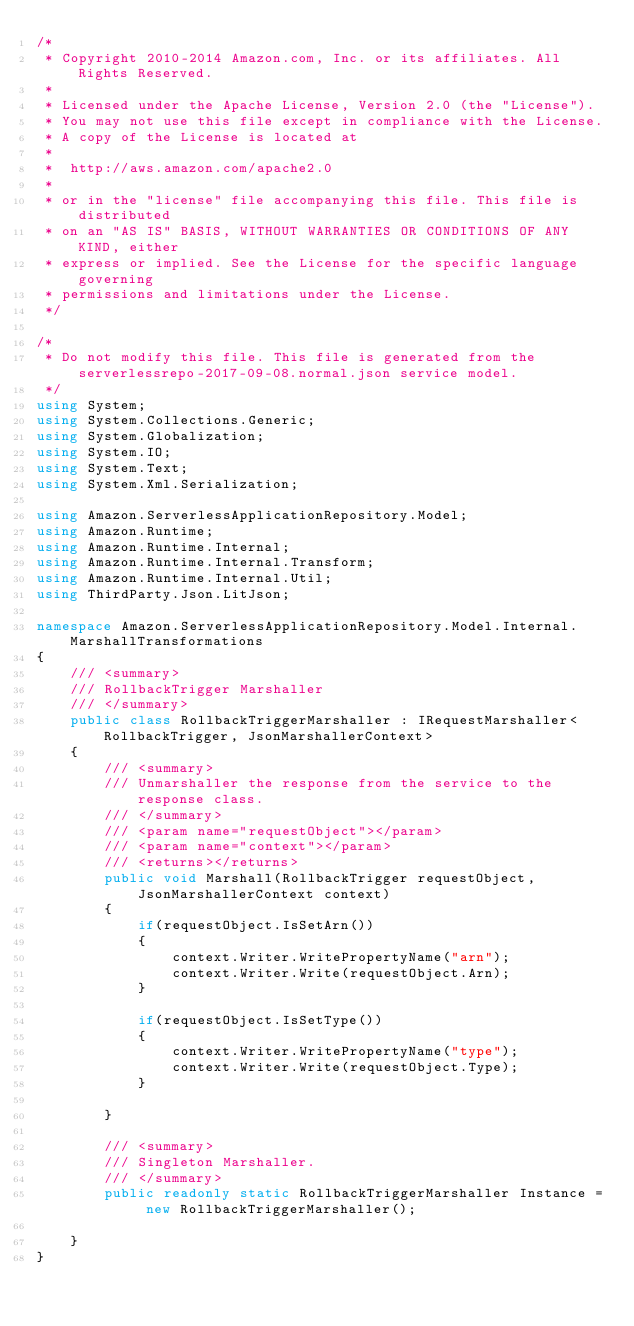<code> <loc_0><loc_0><loc_500><loc_500><_C#_>/*
 * Copyright 2010-2014 Amazon.com, Inc. or its affiliates. All Rights Reserved.
 * 
 * Licensed under the Apache License, Version 2.0 (the "License").
 * You may not use this file except in compliance with the License.
 * A copy of the License is located at
 * 
 *  http://aws.amazon.com/apache2.0
 * 
 * or in the "license" file accompanying this file. This file is distributed
 * on an "AS IS" BASIS, WITHOUT WARRANTIES OR CONDITIONS OF ANY KIND, either
 * express or implied. See the License for the specific language governing
 * permissions and limitations under the License.
 */

/*
 * Do not modify this file. This file is generated from the serverlessrepo-2017-09-08.normal.json service model.
 */
using System;
using System.Collections.Generic;
using System.Globalization;
using System.IO;
using System.Text;
using System.Xml.Serialization;

using Amazon.ServerlessApplicationRepository.Model;
using Amazon.Runtime;
using Amazon.Runtime.Internal;
using Amazon.Runtime.Internal.Transform;
using Amazon.Runtime.Internal.Util;
using ThirdParty.Json.LitJson;

namespace Amazon.ServerlessApplicationRepository.Model.Internal.MarshallTransformations
{
    /// <summary>
    /// RollbackTrigger Marshaller
    /// </summary>       
    public class RollbackTriggerMarshaller : IRequestMarshaller<RollbackTrigger, JsonMarshallerContext> 
    {
        /// <summary>
        /// Unmarshaller the response from the service to the response class.
        /// </summary>  
        /// <param name="requestObject"></param>
        /// <param name="context"></param>
        /// <returns></returns>
        public void Marshall(RollbackTrigger requestObject, JsonMarshallerContext context)
        {
            if(requestObject.IsSetArn())
            {
                context.Writer.WritePropertyName("arn");
                context.Writer.Write(requestObject.Arn);
            }

            if(requestObject.IsSetType())
            {
                context.Writer.WritePropertyName("type");
                context.Writer.Write(requestObject.Type);
            }

        }

        /// <summary>
        /// Singleton Marshaller.
        /// </summary>  
        public readonly static RollbackTriggerMarshaller Instance = new RollbackTriggerMarshaller();

    }
}</code> 